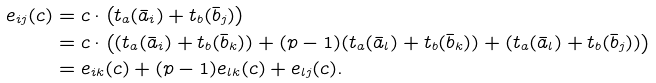Convert formula to latex. <formula><loc_0><loc_0><loc_500><loc_500>e _ { i j } ( c ) & = c \cdot \left ( t _ { a } ( \bar { a } _ { i } ) + t _ { b } ( \bar { b } _ { j } ) \right ) \\ & = c \cdot \left ( ( t _ { a } ( \bar { a } _ { i } ) + t _ { b } ( \bar { b } _ { k } ) ) + ( p - 1 ) ( t _ { a } ( \bar { a } _ { l } ) + t _ { b } ( \bar { b } _ { k } ) ) + ( t _ { a } ( \bar { a } _ { l } ) + t _ { b } ( \bar { b } _ { j } ) ) \right ) \\ & = e _ { i k } ( c ) + ( p - 1 ) e _ { l k } ( c ) + e _ { l j } ( c ) .</formula> 